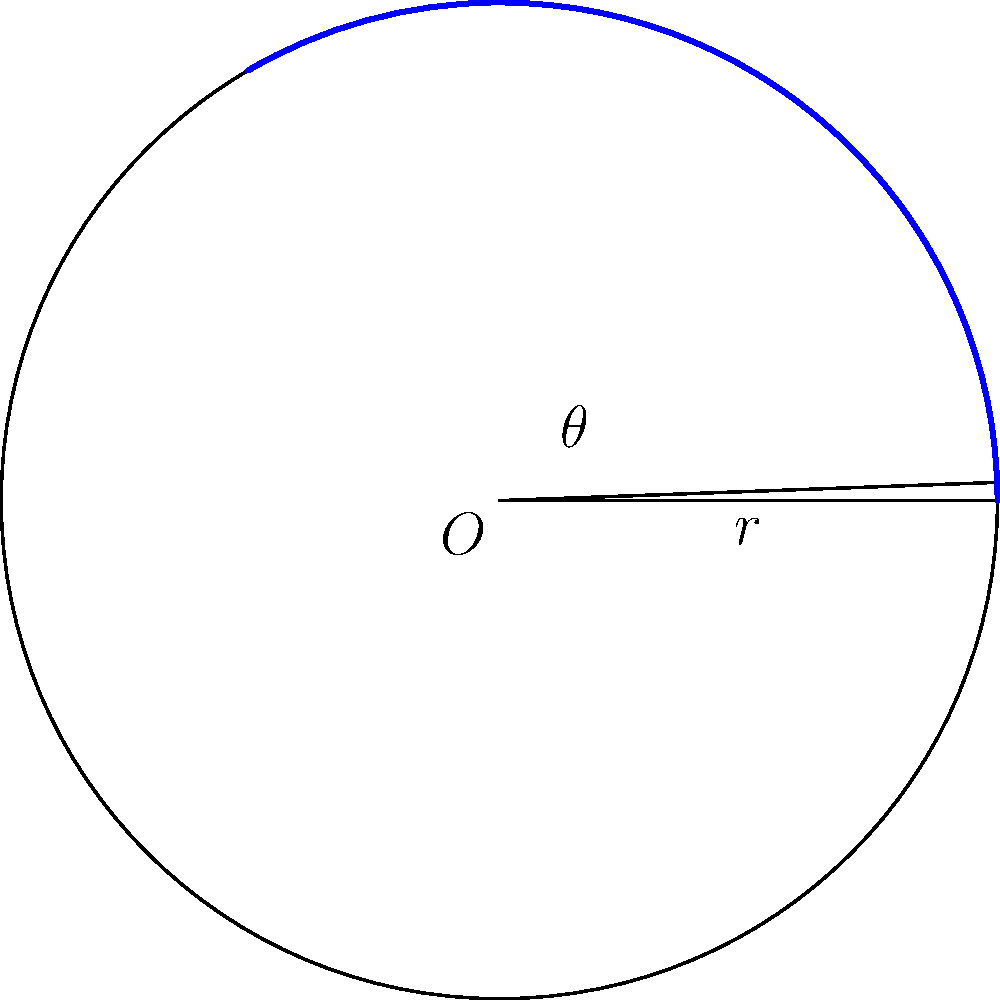As a disgruntled contractor for Google, you're tasked with optimizing the storage allocation for circular sectors in a new mapping algorithm. Given a circle with radius $r = 5$ units and a central angle $\theta = 2.1$ radians, calculate the area of the sector. Round your answer to two decimal places. Let's approach this step-by-step:

1) The formula for the area of a sector is:

   $$A = \frac{1}{2}r^2\theta$$

   where $A$ is the area, $r$ is the radius, and $\theta$ is the central angle in radians.

2) We're given:
   $r = 5$ units
   $\theta = 2.1$ radians

3) Let's substitute these values into our formula:

   $$A = \frac{1}{2} \cdot 5^2 \cdot 2.1$$

4) Simplify:
   $$A = \frac{1}{2} \cdot 25 \cdot 2.1$$
   $$A = 12.5 \cdot 2.1$$

5) Calculate:
   $$A = 26.25$$

6) Rounding to two decimal places:
   $$A \approx 26.25$$

Thus, the area of the sector is approximately 26.25 square units.
Answer: 26.25 square units 